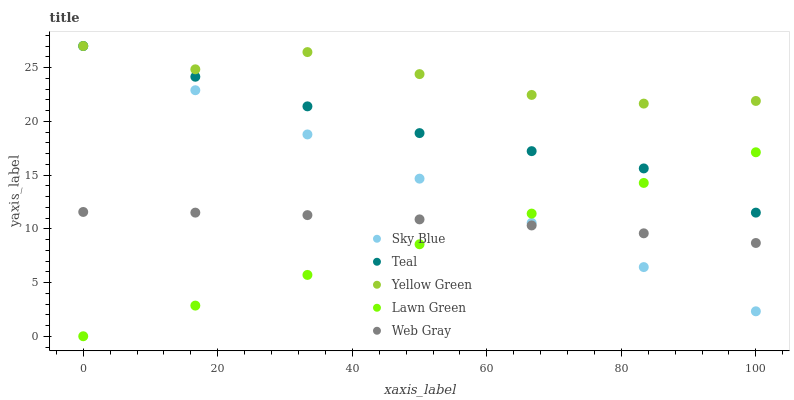Does Lawn Green have the minimum area under the curve?
Answer yes or no. Yes. Does Yellow Green have the maximum area under the curve?
Answer yes or no. Yes. Does Web Gray have the minimum area under the curve?
Answer yes or no. No. Does Web Gray have the maximum area under the curve?
Answer yes or no. No. Is Lawn Green the smoothest?
Answer yes or no. Yes. Is Yellow Green the roughest?
Answer yes or no. Yes. Is Web Gray the smoothest?
Answer yes or no. No. Is Web Gray the roughest?
Answer yes or no. No. Does Lawn Green have the lowest value?
Answer yes or no. Yes. Does Web Gray have the lowest value?
Answer yes or no. No. Does Teal have the highest value?
Answer yes or no. Yes. Does Web Gray have the highest value?
Answer yes or no. No. Is Lawn Green less than Yellow Green?
Answer yes or no. Yes. Is Teal greater than Web Gray?
Answer yes or no. Yes. Does Teal intersect Yellow Green?
Answer yes or no. Yes. Is Teal less than Yellow Green?
Answer yes or no. No. Is Teal greater than Yellow Green?
Answer yes or no. No. Does Lawn Green intersect Yellow Green?
Answer yes or no. No. 